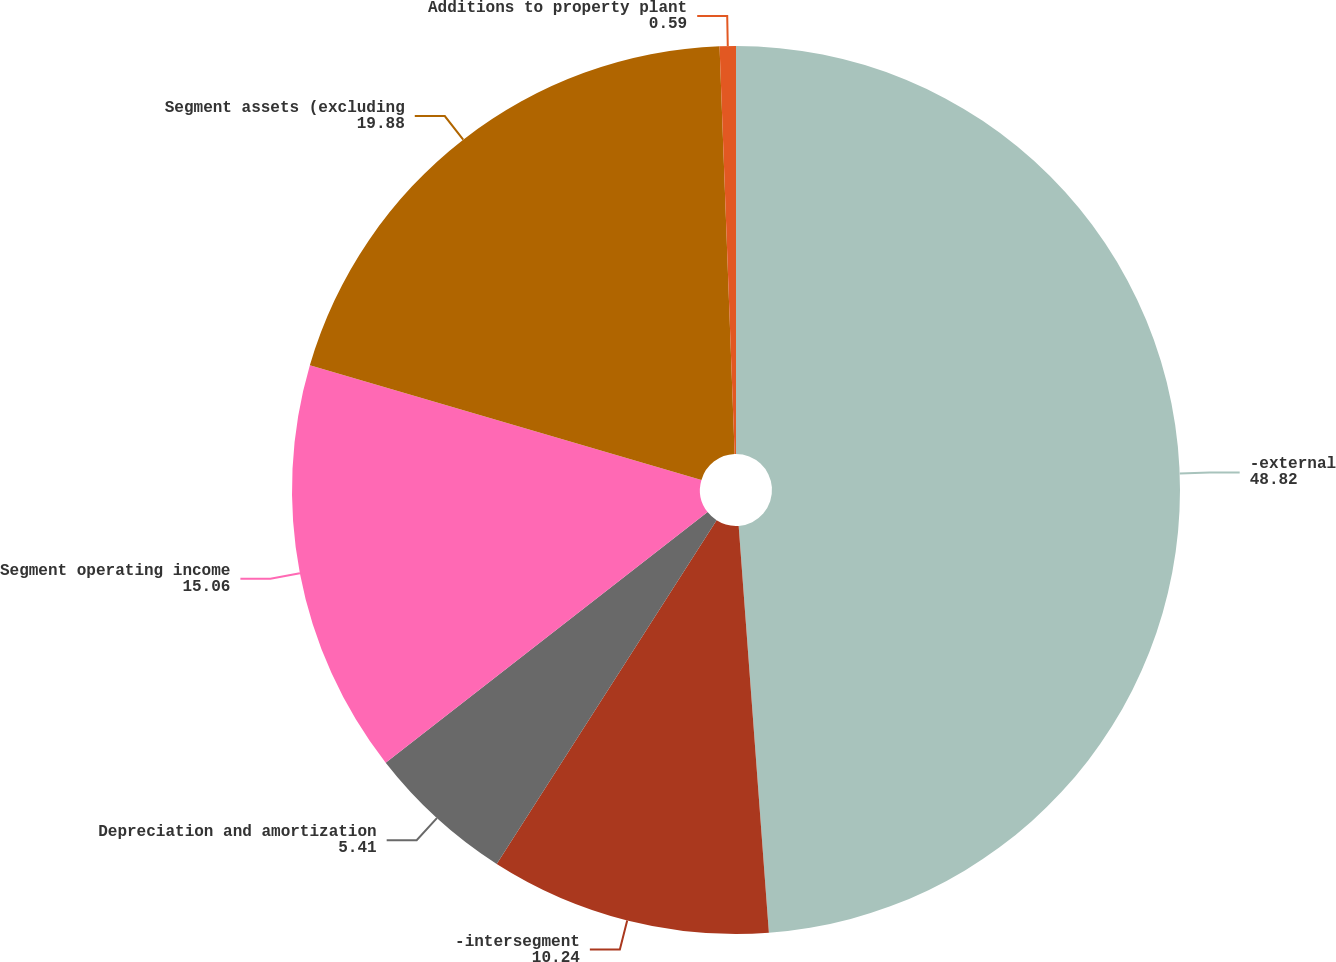<chart> <loc_0><loc_0><loc_500><loc_500><pie_chart><fcel>-external<fcel>-intersegment<fcel>Depreciation and amortization<fcel>Segment operating income<fcel>Segment assets (excluding<fcel>Additions to property plant<nl><fcel>48.82%<fcel>10.24%<fcel>5.41%<fcel>15.06%<fcel>19.88%<fcel>0.59%<nl></chart> 